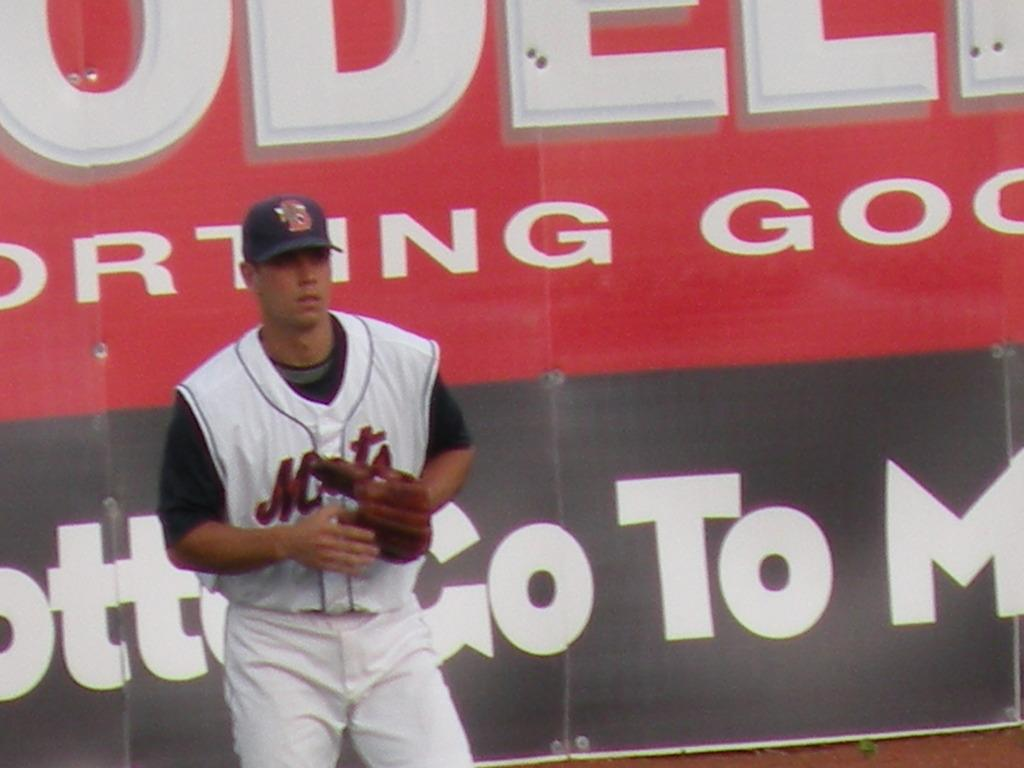<image>
Write a terse but informative summary of the picture. a player that has the name Mets on their jersey 